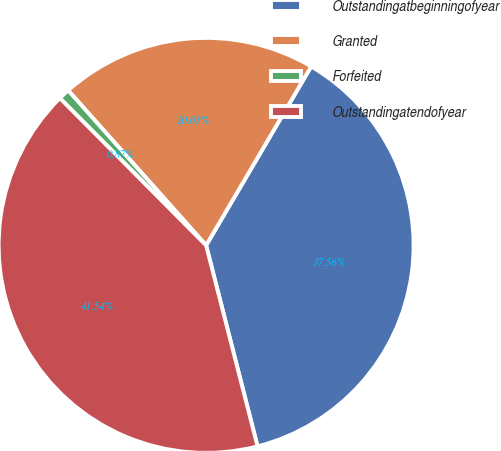Convert chart. <chart><loc_0><loc_0><loc_500><loc_500><pie_chart><fcel>Outstandingatbeginningofyear<fcel>Granted<fcel>Forfeited<fcel>Outstandingatendofyear<nl><fcel>37.56%<fcel>20.03%<fcel>0.87%<fcel>41.54%<nl></chart> 